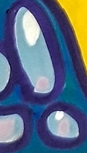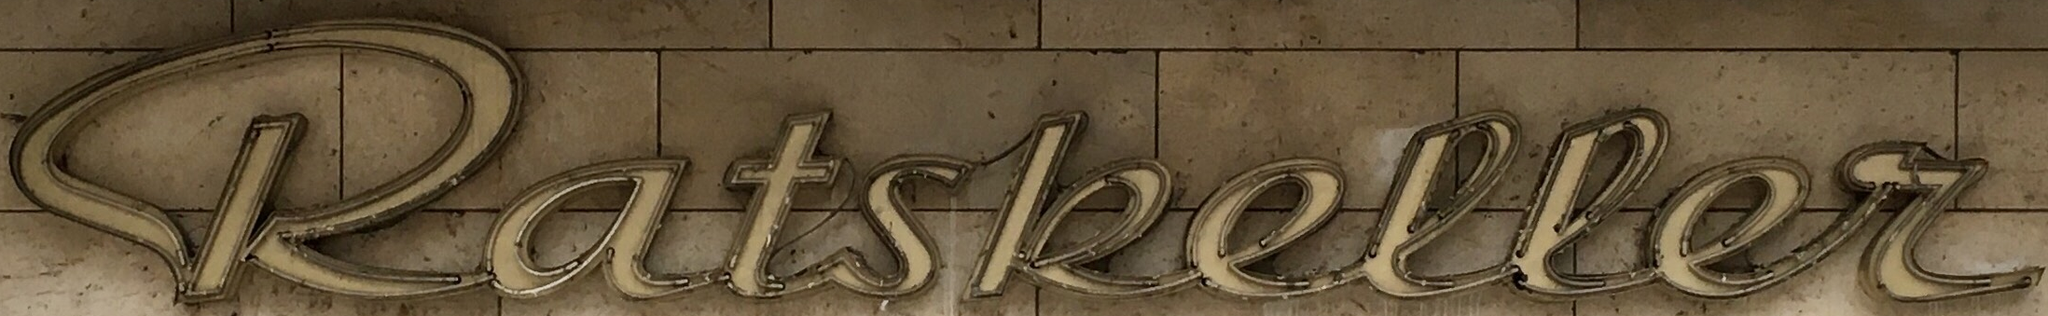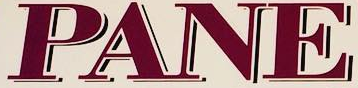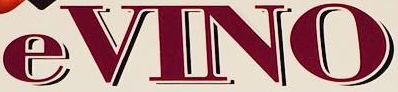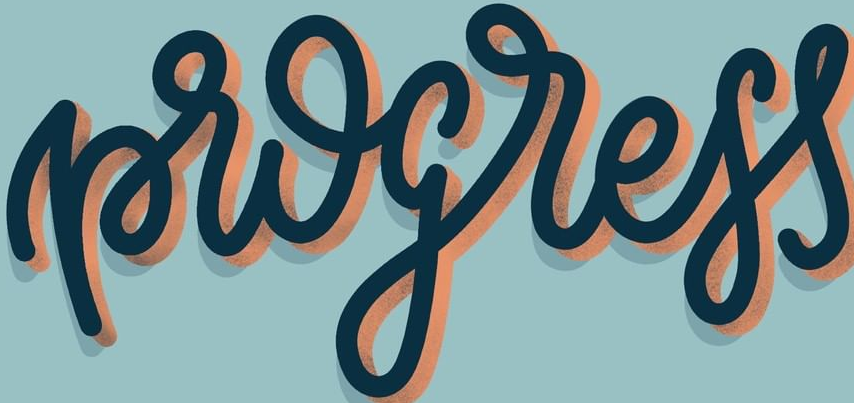Read the text content from these images in order, separated by a semicolon. !; katskeller; PANE; eVINO; progress 